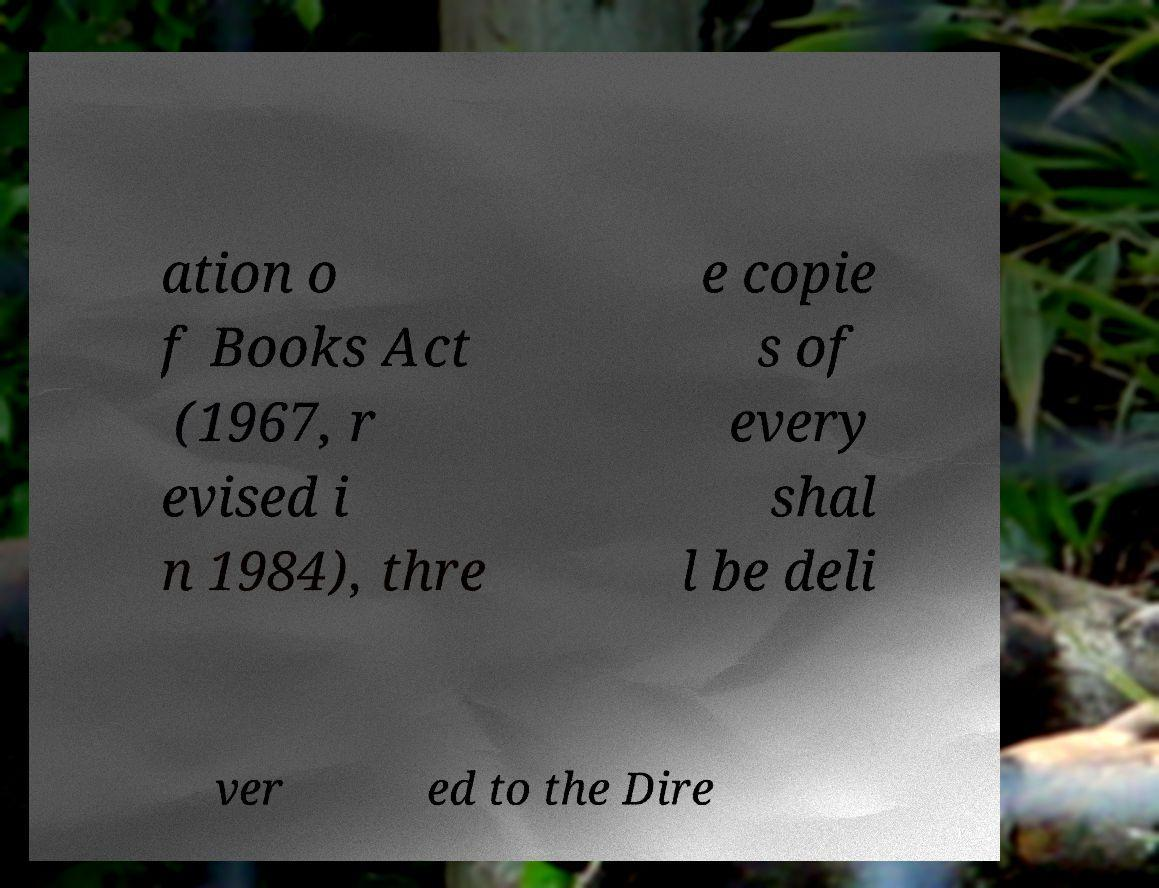Please identify and transcribe the text found in this image. ation o f Books Act (1967, r evised i n 1984), thre e copie s of every shal l be deli ver ed to the Dire 